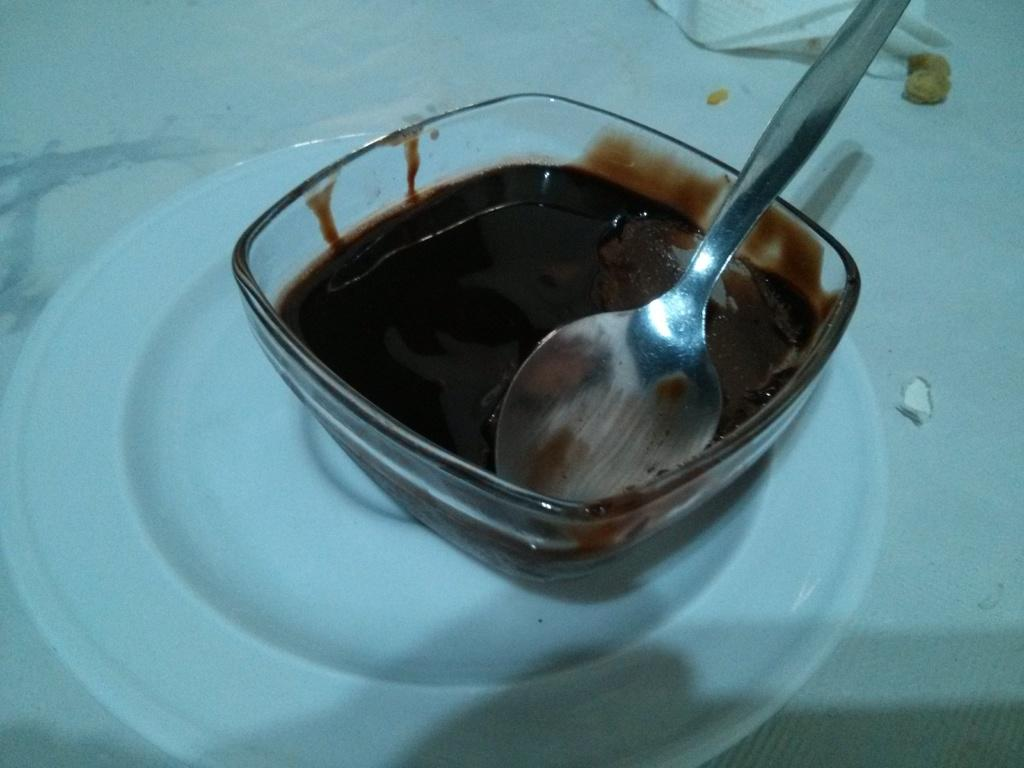What is in the cup that is visible in the image? There is a cup with chocolate liquid in the image. What utensil is present in the image? A spoon is visible in the image. What type of dish is present in the image? There is a white plate in the image. What type of nut is visible on the branch in the image? There is no nut or branch present in the image; it only features a cup with chocolate liquid, a spoon, and a white plate. 